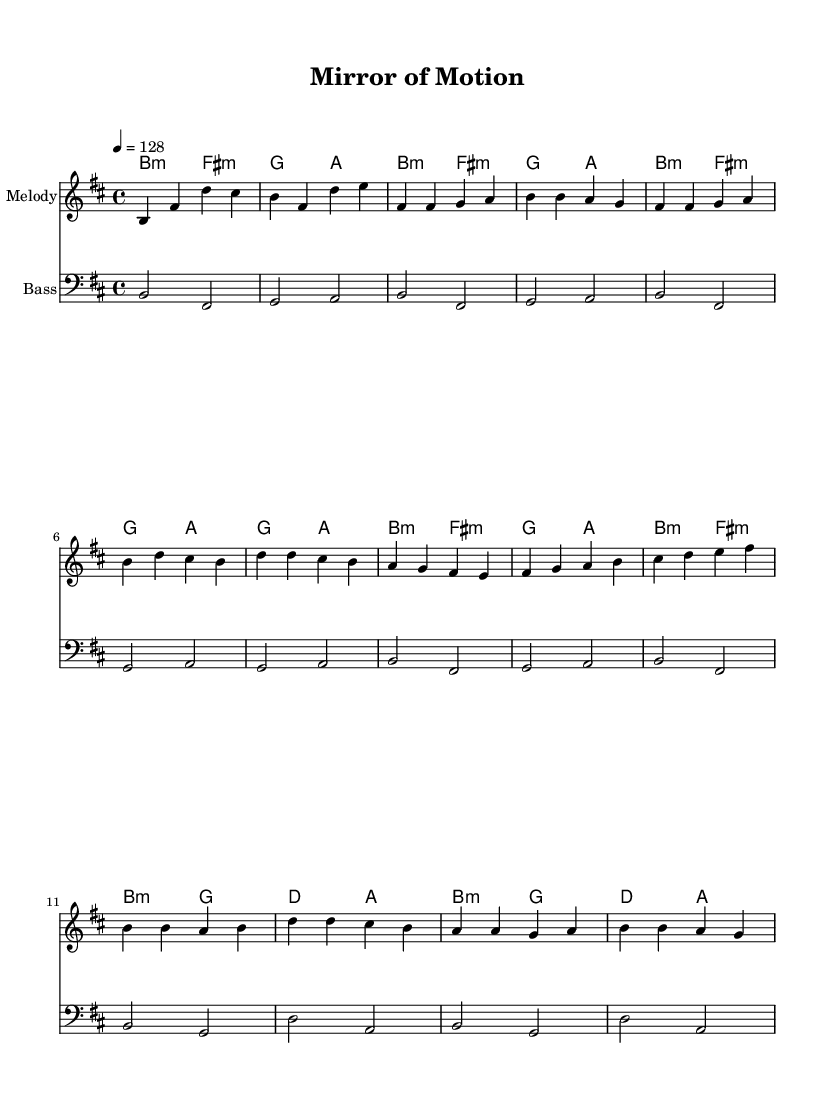What is the key signature of this music? The key signature is indicated by the sharp signs placed on the staff. In this case, the music shows five sharps, which corresponds to the key of B minor.
Answer: B minor What is the time signature of this music? The time signature is located at the beginning of the staff, showing how many beats are in each measure. Here, it shows a 4/4 time signature, meaning there are four beats per measure.
Answer: 4/4 What is the tempo indicated in this score? The tempo is typically found at the top of the score, noted as a specific beat or measure per minute. In this case, it is marked as 4 = 128, indicating the speed of the piece.
Answer: 128 What is the first chord in the introduction? The introduction shows the first chord written in the chord names, which is B minor. To find the answer, we look to the chord above the melody for the initial notes.
Answer: B minor How many measures are in the chorus section? To find the number of measures in the chorus, we look at the section labeled "Chorus" in the music. The chorus consists of four measures, as each segment is separated by a vertical line indicating the end of a measure.
Answer: 4 What does the bass line start with in the intro? The bass line starts with the note B, which can be identified by looking at the first notes of that section in the bass clef. Confirming the note, the first note played is B.
Answer: B What is the harmonic progression for the Pre-Chorus? To understand the harmonic progression, we need to analyze the chord changes in the pre-chorus section. The progression shows G, A, B minor, and F# minor in sequence.
Answer: G A B minor F# minor 